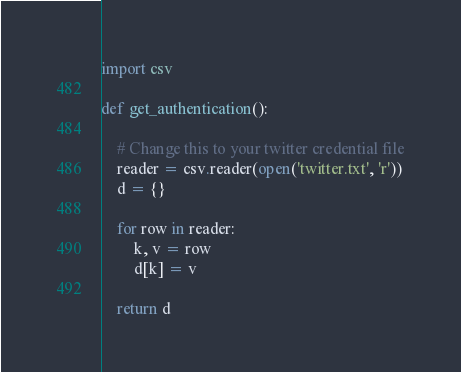Convert code to text. <code><loc_0><loc_0><loc_500><loc_500><_Python_>import csv

def get_authentication():

    # Change this to your twitter credential file
    reader = csv.reader(open('twitter.txt', 'r'))
    d = {}

    for row in reader:
        k, v = row
        d[k] = v

    return d</code> 